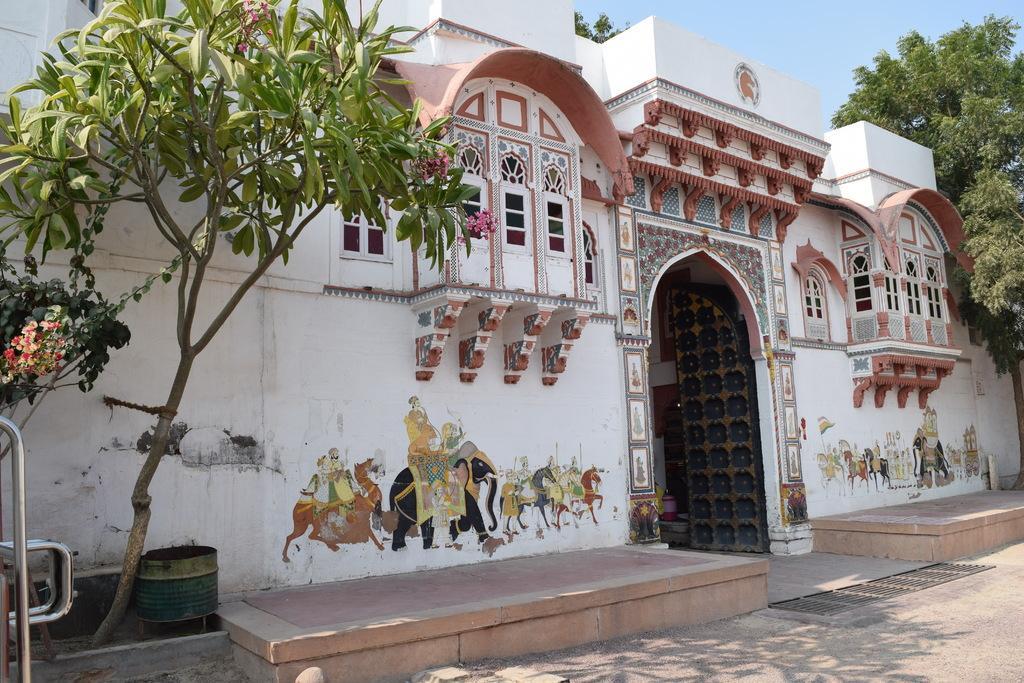Please provide a concise description of this image. In this image there is a metal object and there are trees on the left corner. There are trees on the right corner. There is a road at the bottom. There is a building with an entrance, windows, some paintings. And there is sky at the top. 